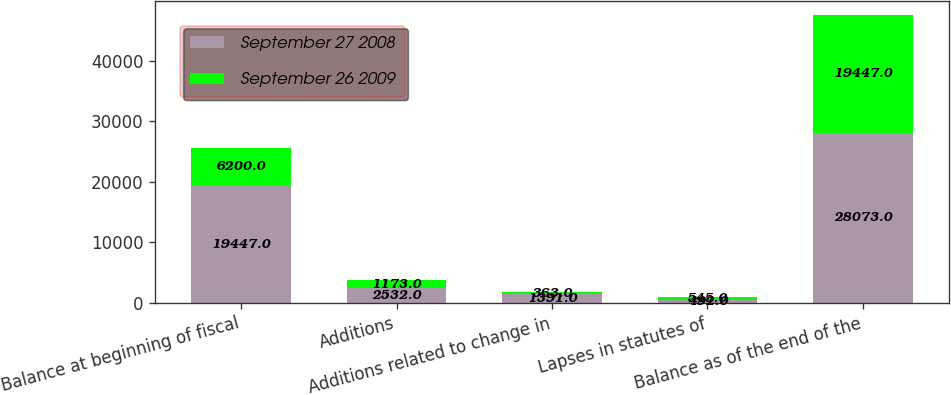<chart> <loc_0><loc_0><loc_500><loc_500><stacked_bar_chart><ecel><fcel>Balance at beginning of fiscal<fcel>Additions<fcel>Additions related to change in<fcel>Lapses in statutes of<fcel>Balance as of the end of the<nl><fcel>September 27 2008<fcel>19447<fcel>2532<fcel>1391<fcel>492<fcel>28073<nl><fcel>September 26 2009<fcel>6200<fcel>1173<fcel>363<fcel>545<fcel>19447<nl></chart> 